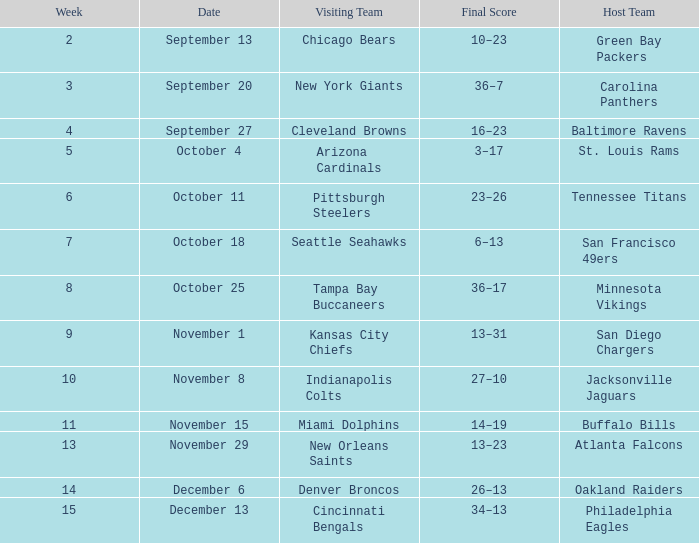What team played on the road against the Buffalo Bills at home ? Miami Dolphins. 